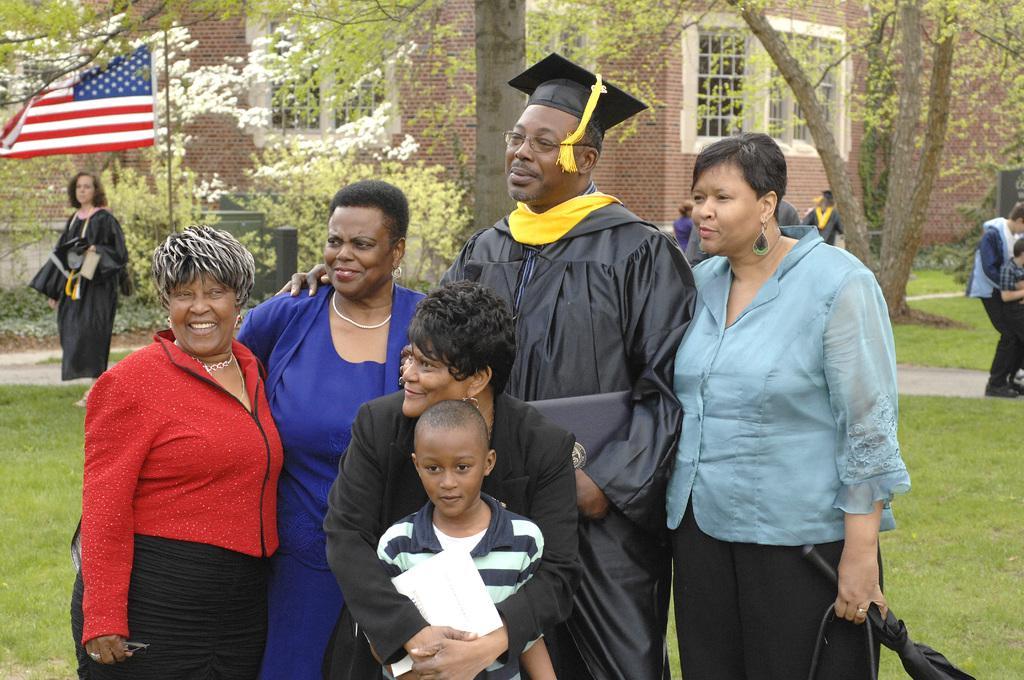In one or two sentences, can you explain what this image depicts? In this image I can see number of people are standing, I can also see smile on few faces. In the background I can see a building, windows, number of trees and a flag. 